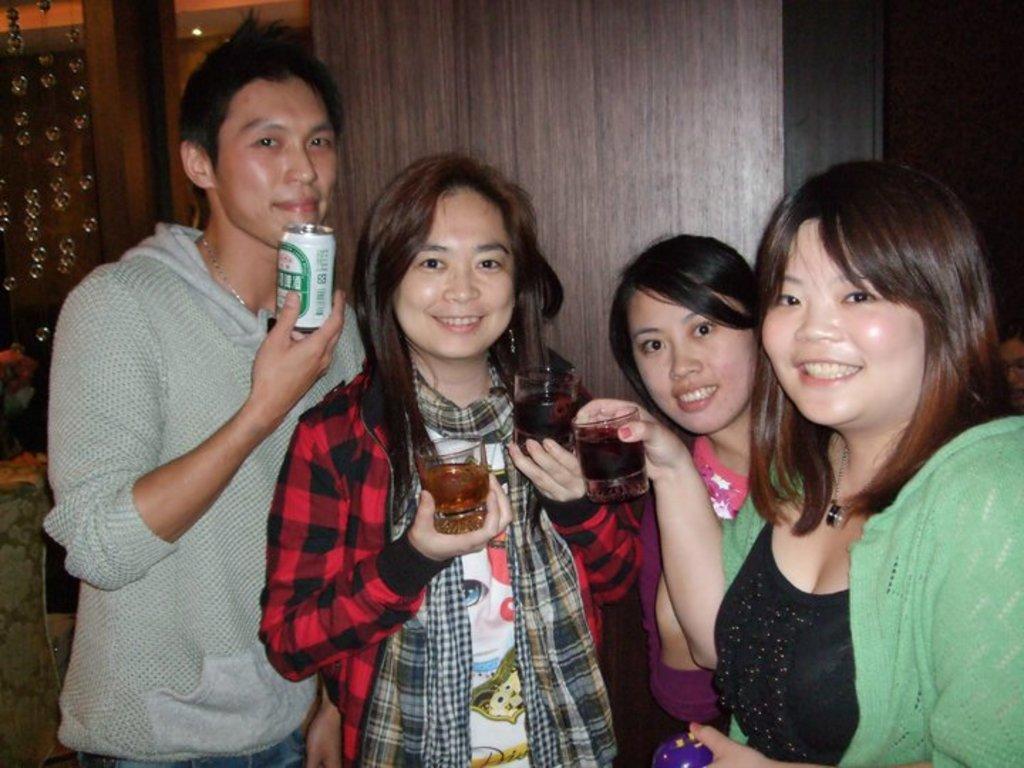Describe this image in one or two sentences. In the middle of the image few people are standing and smiling and holding glasses and tins. Behind them there is a wooden wall. 